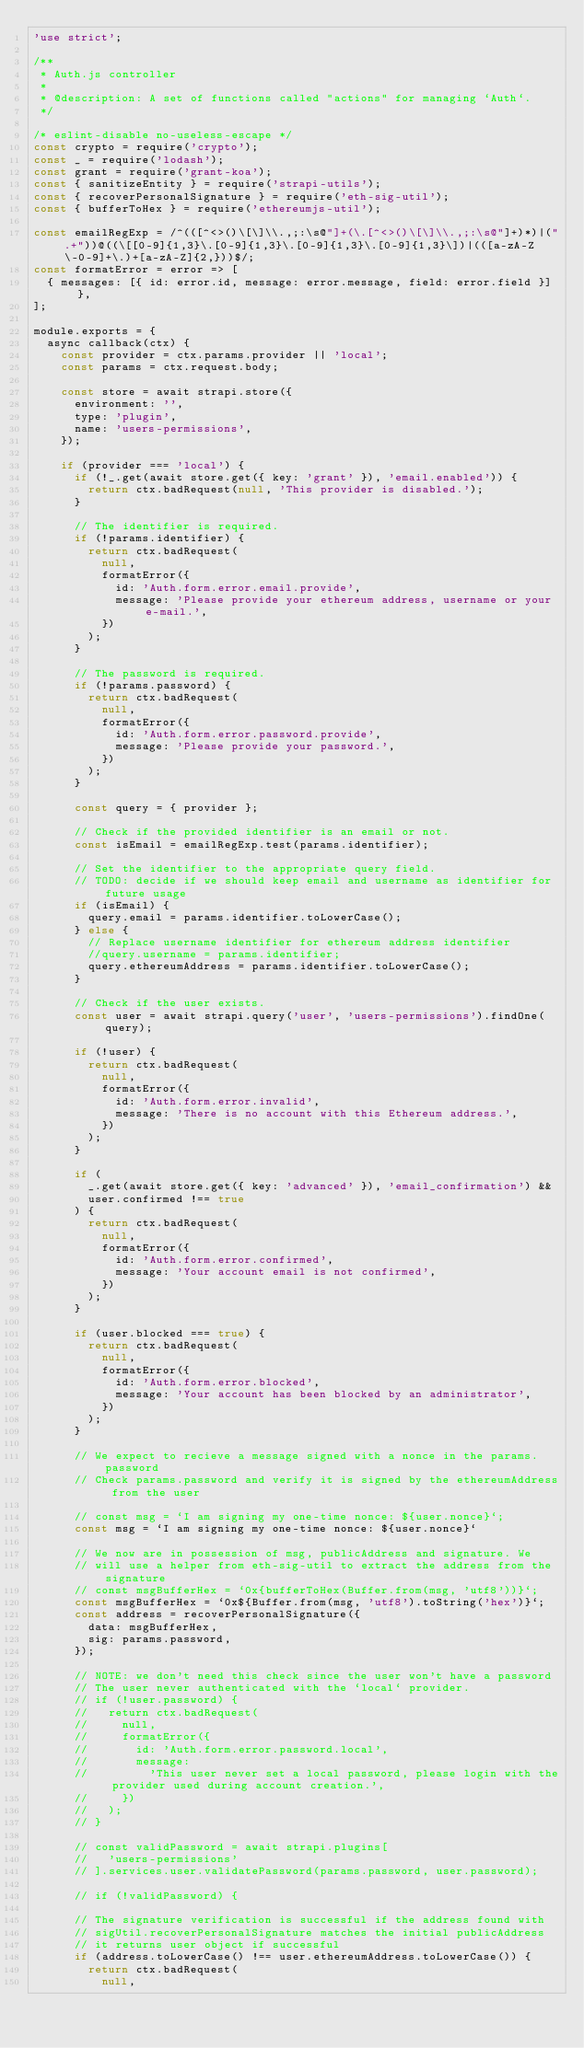<code> <loc_0><loc_0><loc_500><loc_500><_JavaScript_>'use strict';

/**
 * Auth.js controller
 *
 * @description: A set of functions called "actions" for managing `Auth`.
 */

/* eslint-disable no-useless-escape */
const crypto = require('crypto');
const _ = require('lodash');
const grant = require('grant-koa');
const { sanitizeEntity } = require('strapi-utils');
const { recoverPersonalSignature } = require('eth-sig-util');
const { bufferToHex } = require('ethereumjs-util');

const emailRegExp = /^(([^<>()\[\]\\.,;:\s@"]+(\.[^<>()\[\]\\.,;:\s@"]+)*)|(".+"))@((\[[0-9]{1,3}\.[0-9]{1,3}\.[0-9]{1,3}\.[0-9]{1,3}\])|(([a-zA-Z\-0-9]+\.)+[a-zA-Z]{2,}))$/;
const formatError = error => [
  { messages: [{ id: error.id, message: error.message, field: error.field }] },
];

module.exports = {
  async callback(ctx) {
    const provider = ctx.params.provider || 'local';
    const params = ctx.request.body;

    const store = await strapi.store({
      environment: '',
      type: 'plugin',
      name: 'users-permissions',
    });

    if (provider === 'local') {
      if (!_.get(await store.get({ key: 'grant' }), 'email.enabled')) {
        return ctx.badRequest(null, 'This provider is disabled.');
      }

      // The identifier is required.
      if (!params.identifier) {
        return ctx.badRequest(
          null,
          formatError({
            id: 'Auth.form.error.email.provide',
            message: 'Please provide your ethereum address, username or your e-mail.',
          })
        );
      }

      // The password is required.
      if (!params.password) {
        return ctx.badRequest(
          null,
          formatError({
            id: 'Auth.form.error.password.provide',
            message: 'Please provide your password.',
          })
        );
      }

      const query = { provider };

      // Check if the provided identifier is an email or not.
      const isEmail = emailRegExp.test(params.identifier);

      // Set the identifier to the appropriate query field.
      // TODO: decide if we should keep email and username as identifier for future usage
      if (isEmail) {
        query.email = params.identifier.toLowerCase();
      } else {
        // Replace username identifier for ethereum address identifier
        //query.username = params.identifier;
        query.ethereumAddress = params.identifier.toLowerCase();
      }

      // Check if the user exists.      
      const user = await strapi.query('user', 'users-permissions').findOne(query);

      if (!user) {
        return ctx.badRequest(
          null,
          formatError({
            id: 'Auth.form.error.invalid',
            message: 'There is no account with this Ethereum address.',
          })
        );
      }

      if (
        _.get(await store.get({ key: 'advanced' }), 'email_confirmation') &&
        user.confirmed !== true
      ) {
        return ctx.badRequest(
          null,
          formatError({
            id: 'Auth.form.error.confirmed',
            message: 'Your account email is not confirmed',
          })
        );
      }

      if (user.blocked === true) {
        return ctx.badRequest(
          null,
          formatError({
            id: 'Auth.form.error.blocked',
            message: 'Your account has been blocked by an administrator',
          })
        );
      }

      // We expect to recieve a message signed with a nonce in the params.password
      // Check params.password and verify it is signed by the ethereumAddress from the user

      // const msg = `I am signing my one-time nonce: ${user.nonce}`;
      const msg = `I am signing my one-time nonce: ${user.nonce}`

      // We now are in possession of msg, publicAddress and signature. We
      // will use a helper from eth-sig-util to extract the address from the signature
      // const msgBufferHex = `0x{bufferToHex(Buffer.from(msg, 'utf8'))}`;
      const msgBufferHex = `0x${Buffer.from(msg, 'utf8').toString('hex')}`;
      const address = recoverPersonalSignature({
        data: msgBufferHex,
        sig: params.password,
      });

      // NOTE: we don't need this check since the user won't have a password
      // The user never authenticated with the `local` provider.
      // if (!user.password) {
      //   return ctx.badRequest(
      //     null,
      //     formatError({
      //       id: 'Auth.form.error.password.local',
      //       message:
      //         'This user never set a local password, please login with the provider used during account creation.',
      //     })
      //   );
      // }

      // const validPassword = await strapi.plugins[
      //   'users-permissions'
      // ].services.user.validatePassword(params.password, user.password);

      // if (!validPassword) {

      // The signature verification is successful if the address found with
      // sigUtil.recoverPersonalSignature matches the initial publicAddress
      // it returns user object if successful
      if (address.toLowerCase() !== user.ethereumAddress.toLowerCase()) {
        return ctx.badRequest(
          null,</code> 